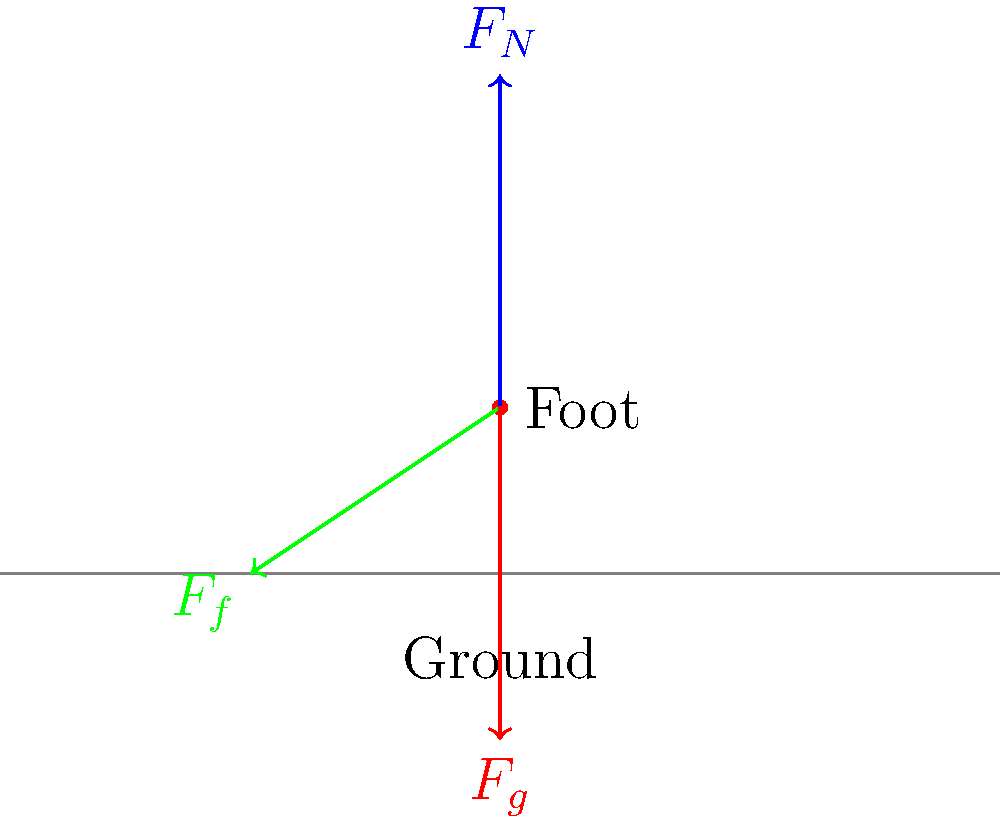As an elite athlete familiar with injury prevention, analyze the force diagram of a runner's foot during the stance phase. If the runner is maintaining a constant speed on a flat surface, what is the relationship between the normal force ($F_N$) and the gravitational force ($F_g$)? To answer this question, let's analyze the forces acting on the runner's foot during the stance phase:

1. Gravitational force ($F_g$): This is the downward force due to the runner's weight.
2. Normal force ($F_N$): This is the upward force exerted by the ground on the runner's foot.
3. Friction force ($F_f$): This is the horizontal force that opposes the runner's motion.

Now, let's consider the conditions:
- The runner is moving at a constant speed on a flat surface.
- We're looking at the vertical forces (normal and gravitational).

For an object moving at constant velocity (including constant speed in a straight line):
- The net force in any direction must be zero.

In the vertical direction:
- Net vertical force = $F_N - F_g = 0$
- This means $F_N = F_g$

The normal force must equal the gravitational force for the runner to maintain a constant vertical position (neither sinking into the ground nor lifting off).

This balance of forces is crucial for injury prevention, as it ensures proper load distribution and helps maintain proper form during running.
Answer: $F_N = F_g$ 